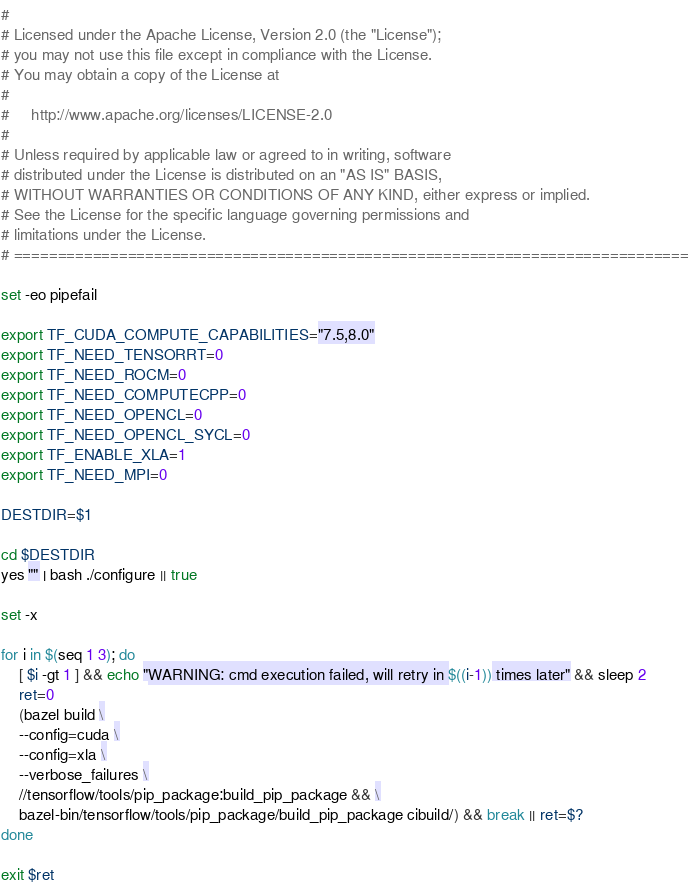Convert code to text. <code><loc_0><loc_0><loc_500><loc_500><_Bash_>#
# Licensed under the Apache License, Version 2.0 (the "License");
# you may not use this file except in compliance with the License.
# You may obtain a copy of the License at
#
#     http://www.apache.org/licenses/LICENSE-2.0
#
# Unless required by applicable law or agreed to in writing, software
# distributed under the License is distributed on an "AS IS" BASIS,
# WITHOUT WARRANTIES OR CONDITIONS OF ANY KIND, either express or implied.
# See the License for the specific language governing permissions and
# limitations under the License.
# =============================================================================

set -eo pipefail

export TF_CUDA_COMPUTE_CAPABILITIES="7.5,8.0"
export TF_NEED_TENSORRT=0
export TF_NEED_ROCM=0
export TF_NEED_COMPUTECPP=0
export TF_NEED_OPENCL=0
export TF_NEED_OPENCL_SYCL=0
export TF_ENABLE_XLA=1
export TF_NEED_MPI=0

DESTDIR=$1

cd $DESTDIR
yes "" | bash ./configure || true

set -x

for i in $(seq 1 3); do
    [ $i -gt 1 ] && echo "WARNING: cmd execution failed, will retry in $((i-1)) times later" && sleep 2
    ret=0
    (bazel build \
    --config=cuda \
    --config=xla \
    --verbose_failures \
    //tensorflow/tools/pip_package:build_pip_package && \
    bazel-bin/tensorflow/tools/pip_package/build_pip_package cibuild/) && break || ret=$?
done

exit $ret

</code> 